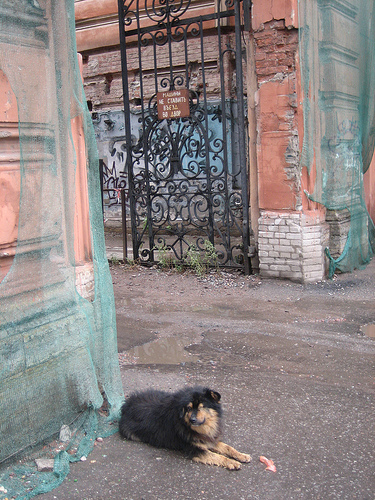<image>
Is the board behind the dog? Yes. From this viewpoint, the board is positioned behind the dog, with the dog partially or fully occluding the board. Is there a dog on the wall? No. The dog is not positioned on the wall. They may be near each other, but the dog is not supported by or resting on top of the wall. 